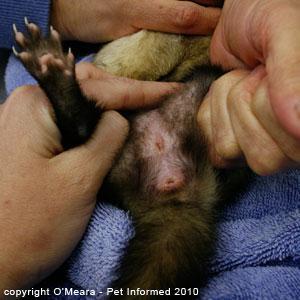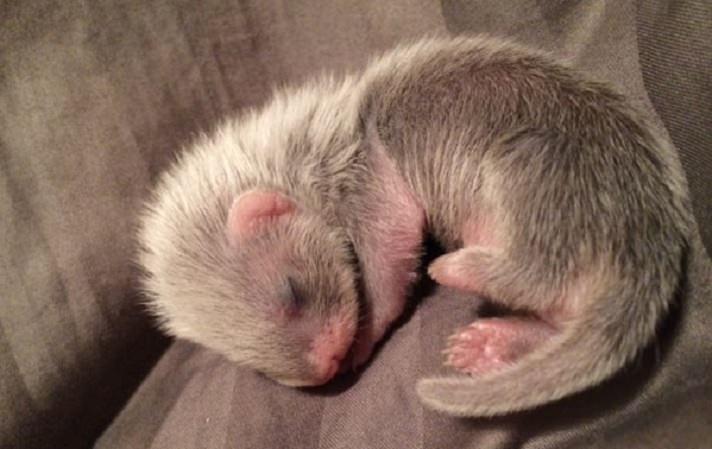The first image is the image on the left, the second image is the image on the right. Evaluate the accuracy of this statement regarding the images: "Someone is holding all the animals in the images.". Is it true? Answer yes or no. No. 